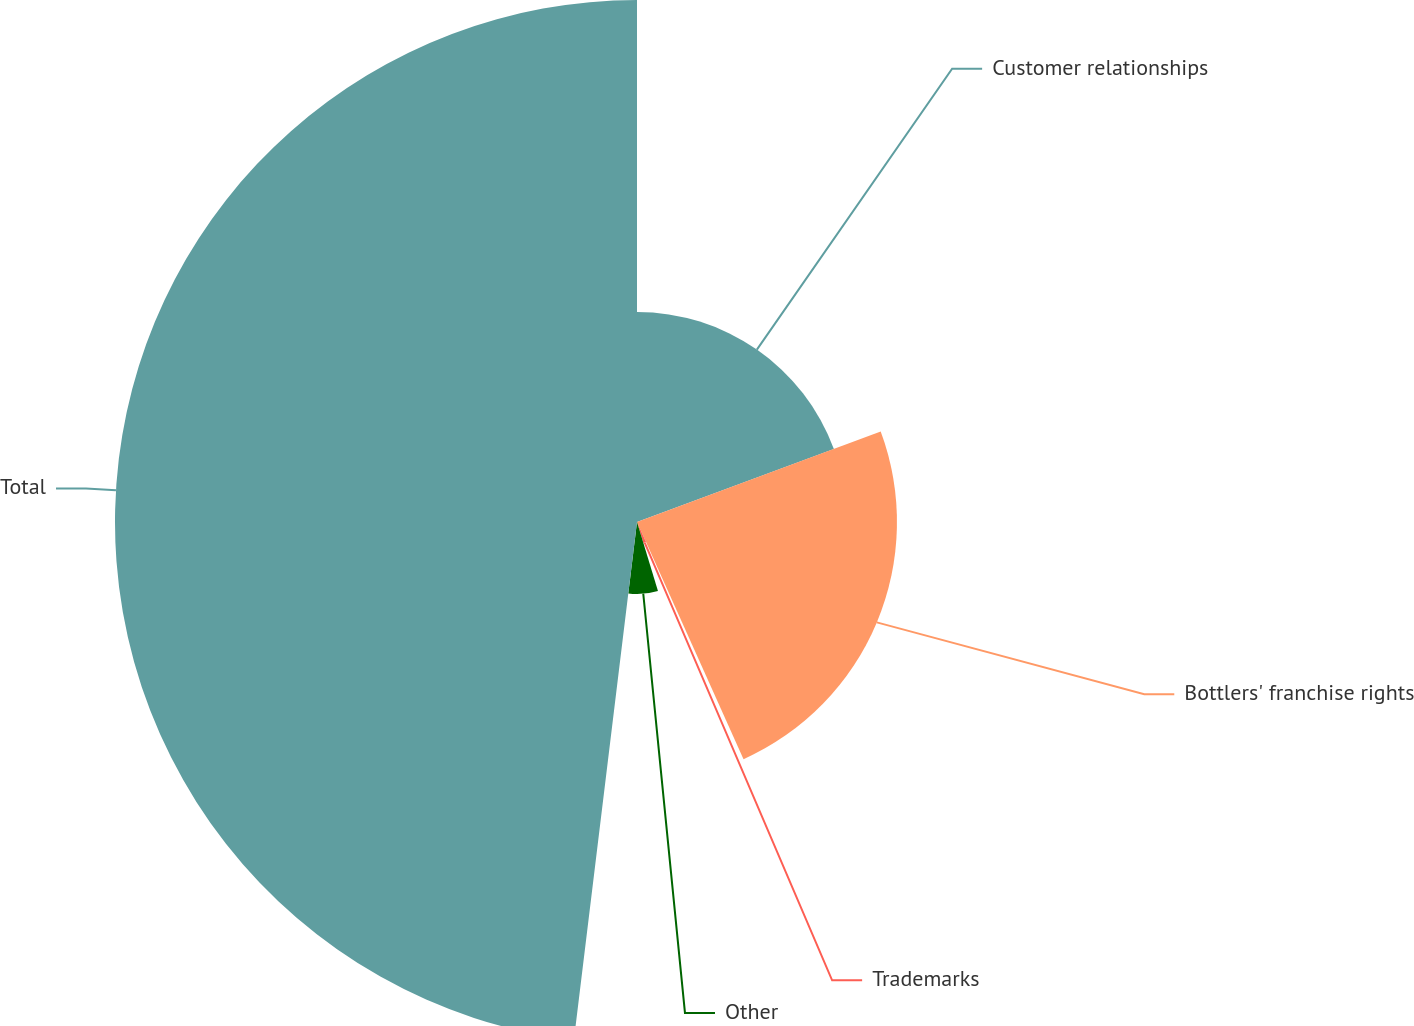Convert chart to OTSL. <chart><loc_0><loc_0><loc_500><loc_500><pie_chart><fcel>Customer relationships<fcel>Bottlers' franchise rights<fcel>Trademarks<fcel>Other<fcel>Total<nl><fcel>19.34%<fcel>23.94%<fcel>2.02%<fcel>6.63%<fcel>48.07%<nl></chart> 